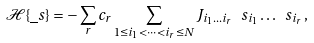<formula> <loc_0><loc_0><loc_500><loc_500>\mathcal { H } \{ \underline { \ } s \} = - \sum _ { r } c _ { r } \sum _ { 1 \leq i _ { 1 } < \dots < i _ { r } \leq N } J _ { i _ { 1 } \dots i _ { r } } \ s _ { i _ { 1 } } \dots \ s _ { i _ { r } } \, ,</formula> 